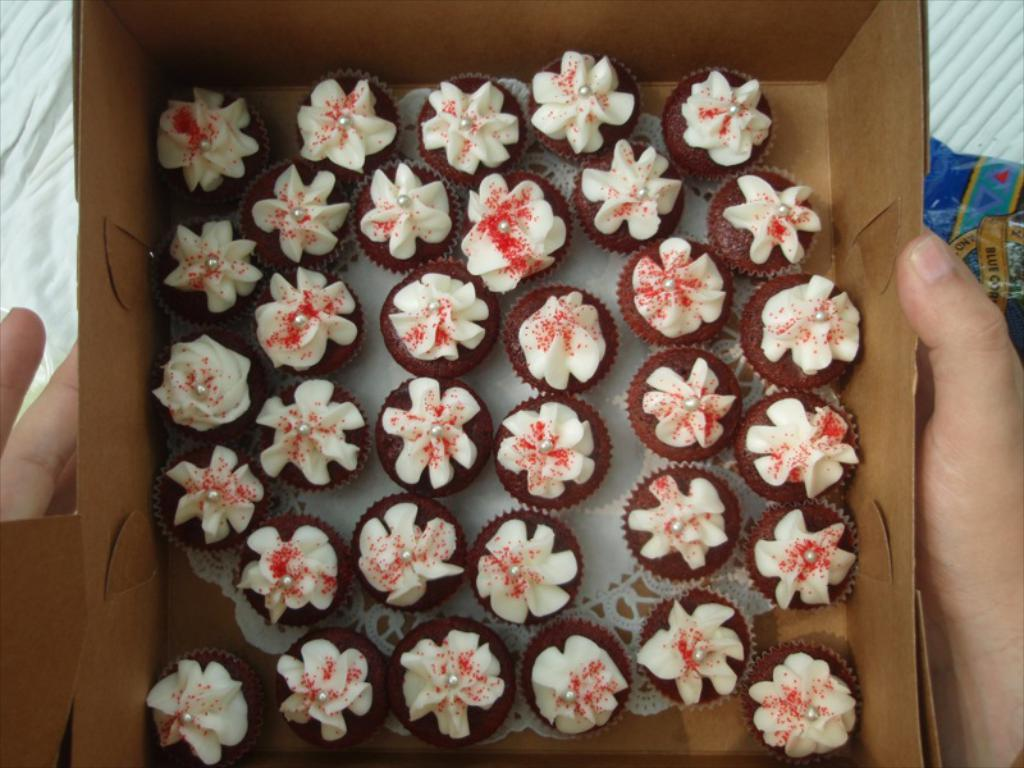What is the person holding in the image? The person is holding a box in the image. What part of the person's body can be seen in the image? The person's hands are visible in the image. What is inside the box that the person is holding? There are cupcakes with cream inside the box. What type of ship can be seen in the image? There is no ship present in the image. Is the person in jail in the image? There is no indication of a jail or any person being in jail in the image. 